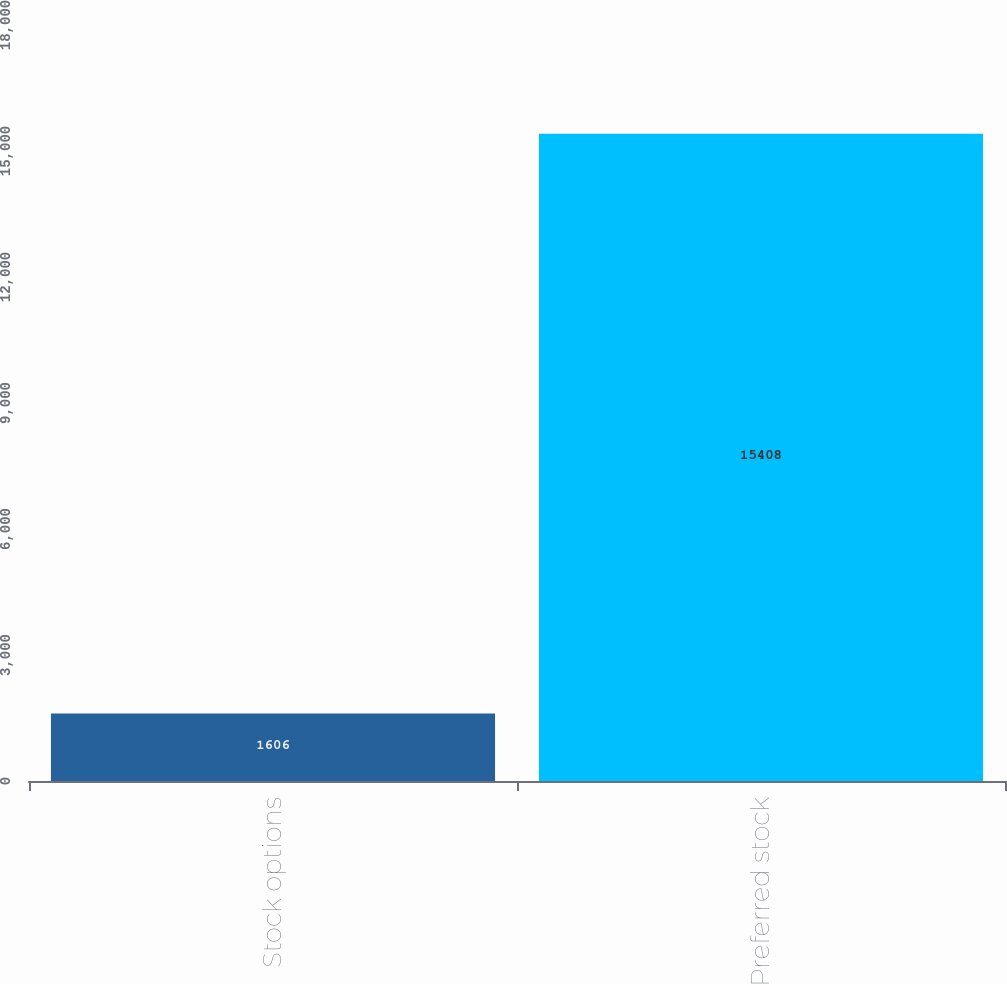<chart> <loc_0><loc_0><loc_500><loc_500><bar_chart><fcel>Stock options<fcel>Preferred stock<nl><fcel>1606<fcel>15408<nl></chart> 